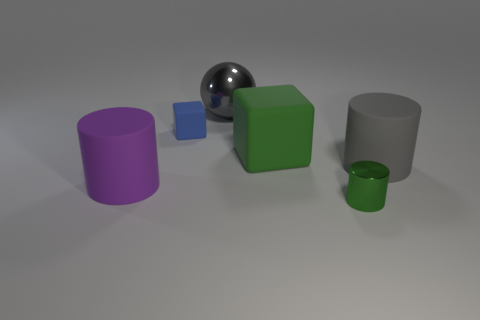Subtract all large cylinders. How many cylinders are left? 1 Subtract 1 cylinders. How many cylinders are left? 2 Add 3 gray metallic balls. How many objects exist? 9 Subtract all balls. How many objects are left? 5 Subtract all big green cubes. Subtract all big cylinders. How many objects are left? 3 Add 2 purple matte things. How many purple matte things are left? 3 Add 5 metallic cylinders. How many metallic cylinders exist? 6 Subtract 0 yellow balls. How many objects are left? 6 